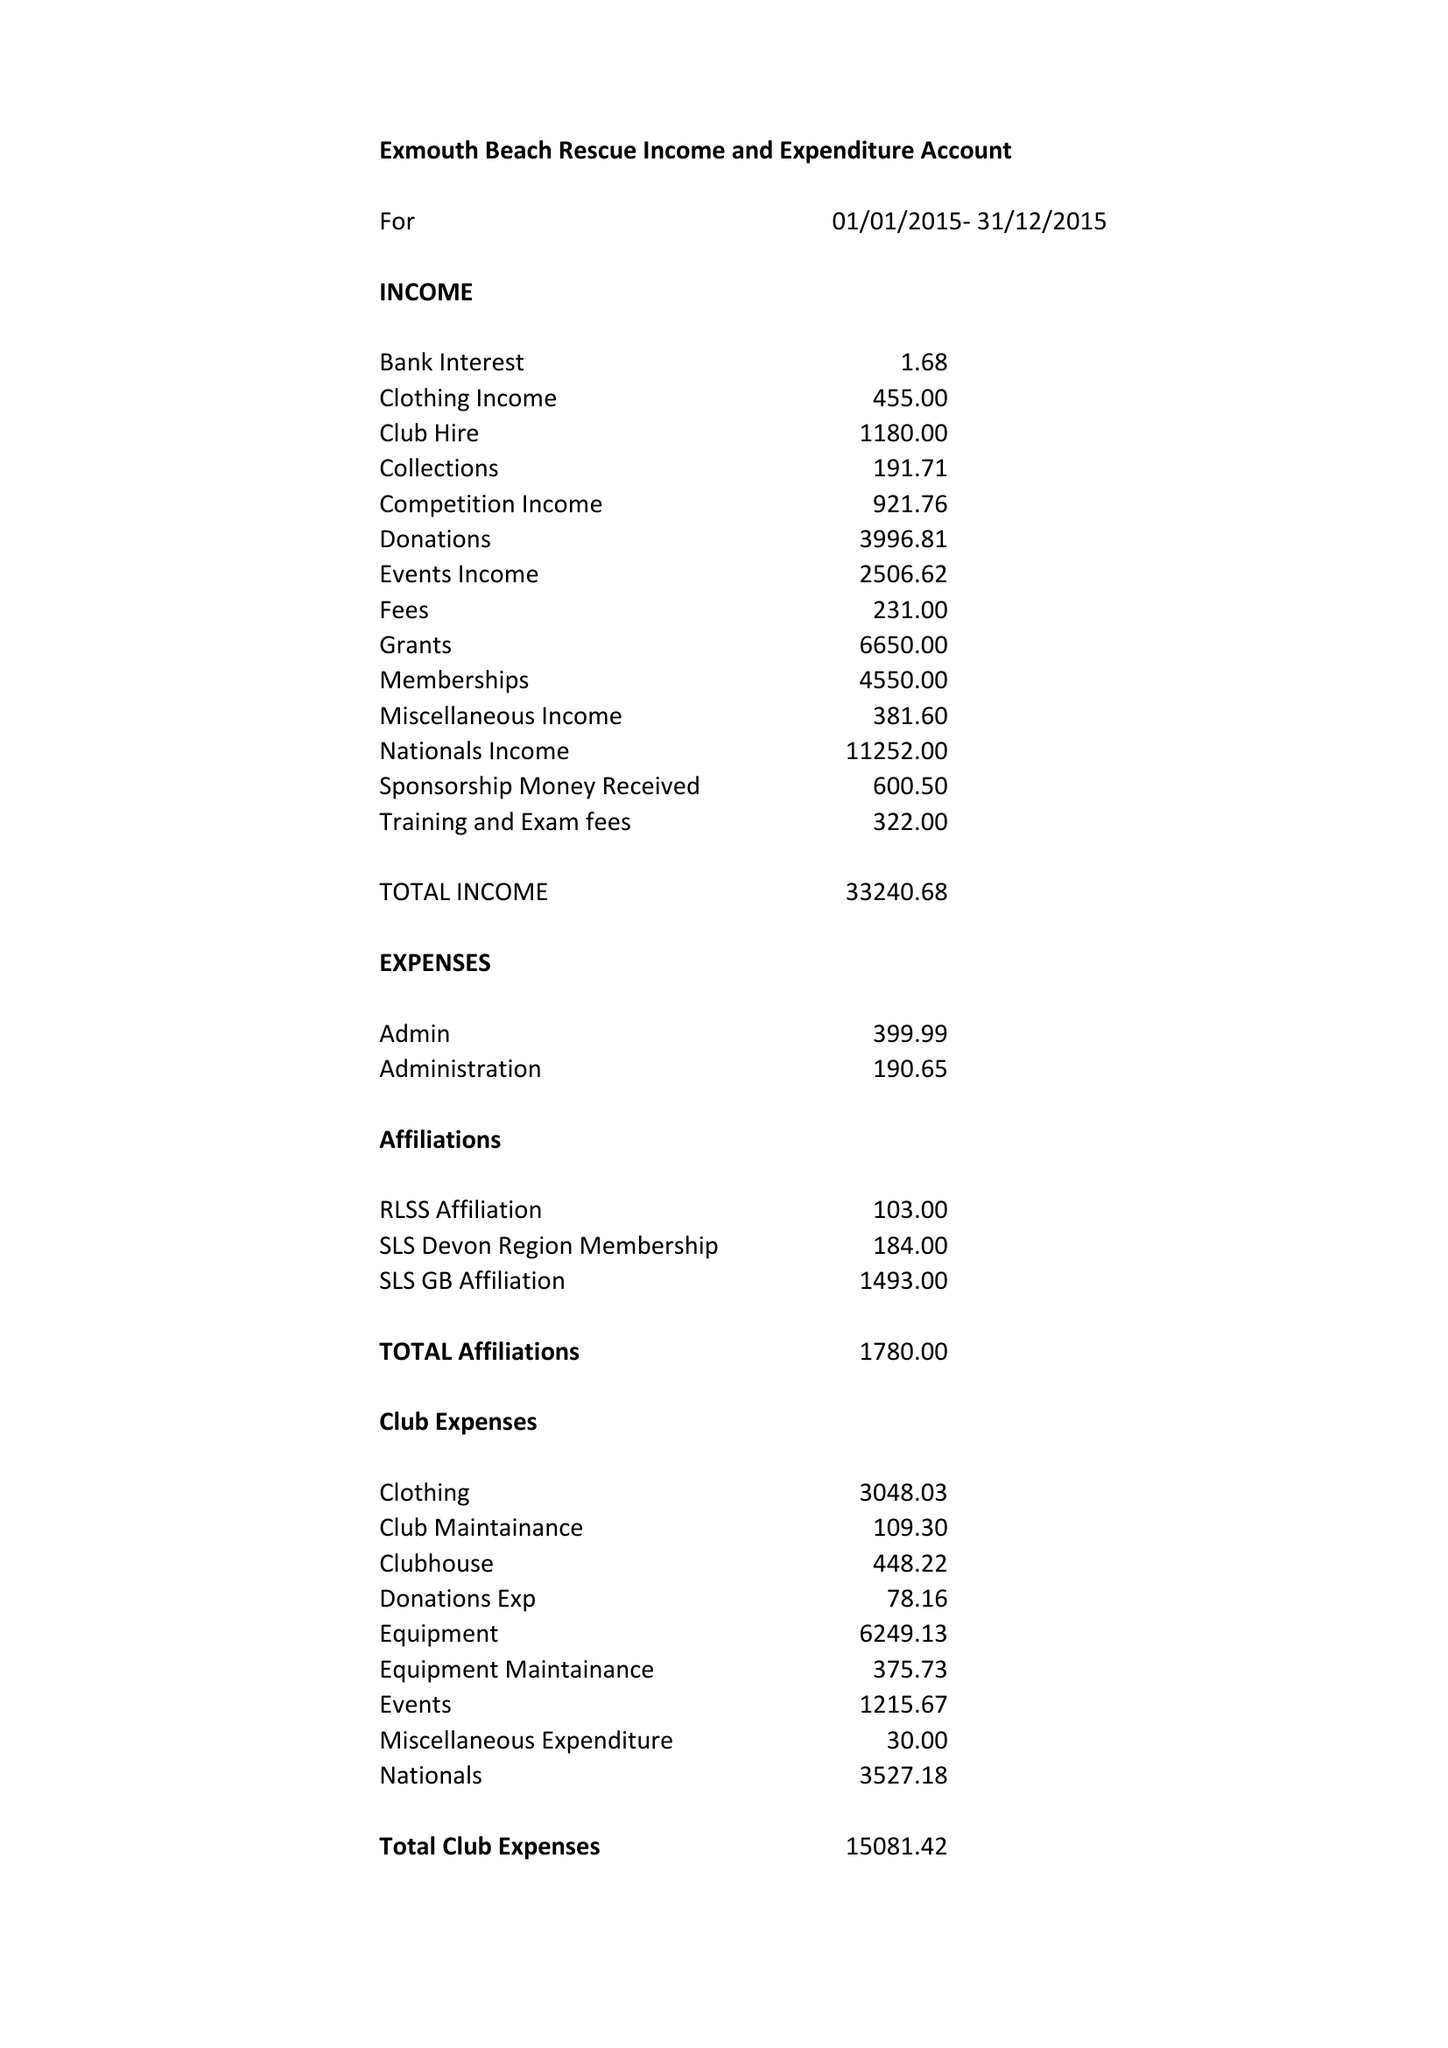What is the value for the income_annually_in_british_pounds?
Answer the question using a single word or phrase. 33241.00 